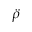<formula> <loc_0><loc_0><loc_500><loc_500>\ddot { \rho }</formula> 